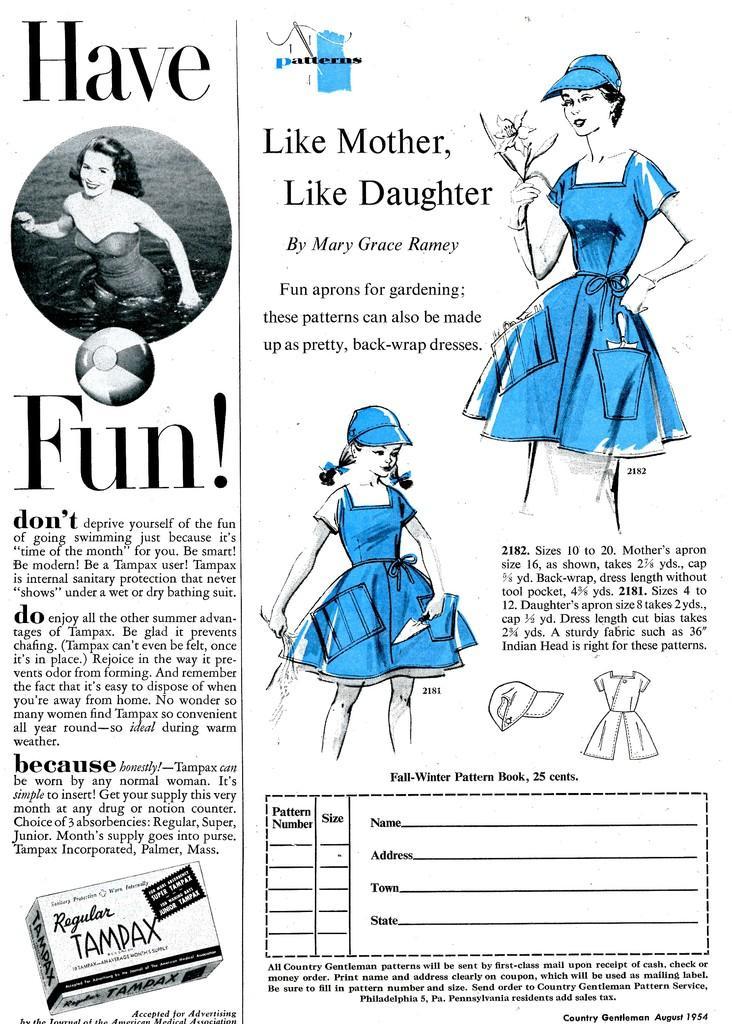Can you describe this image briefly? In this picture I can see the poster. I can see girl picture and woman picture. I can see text on it. 